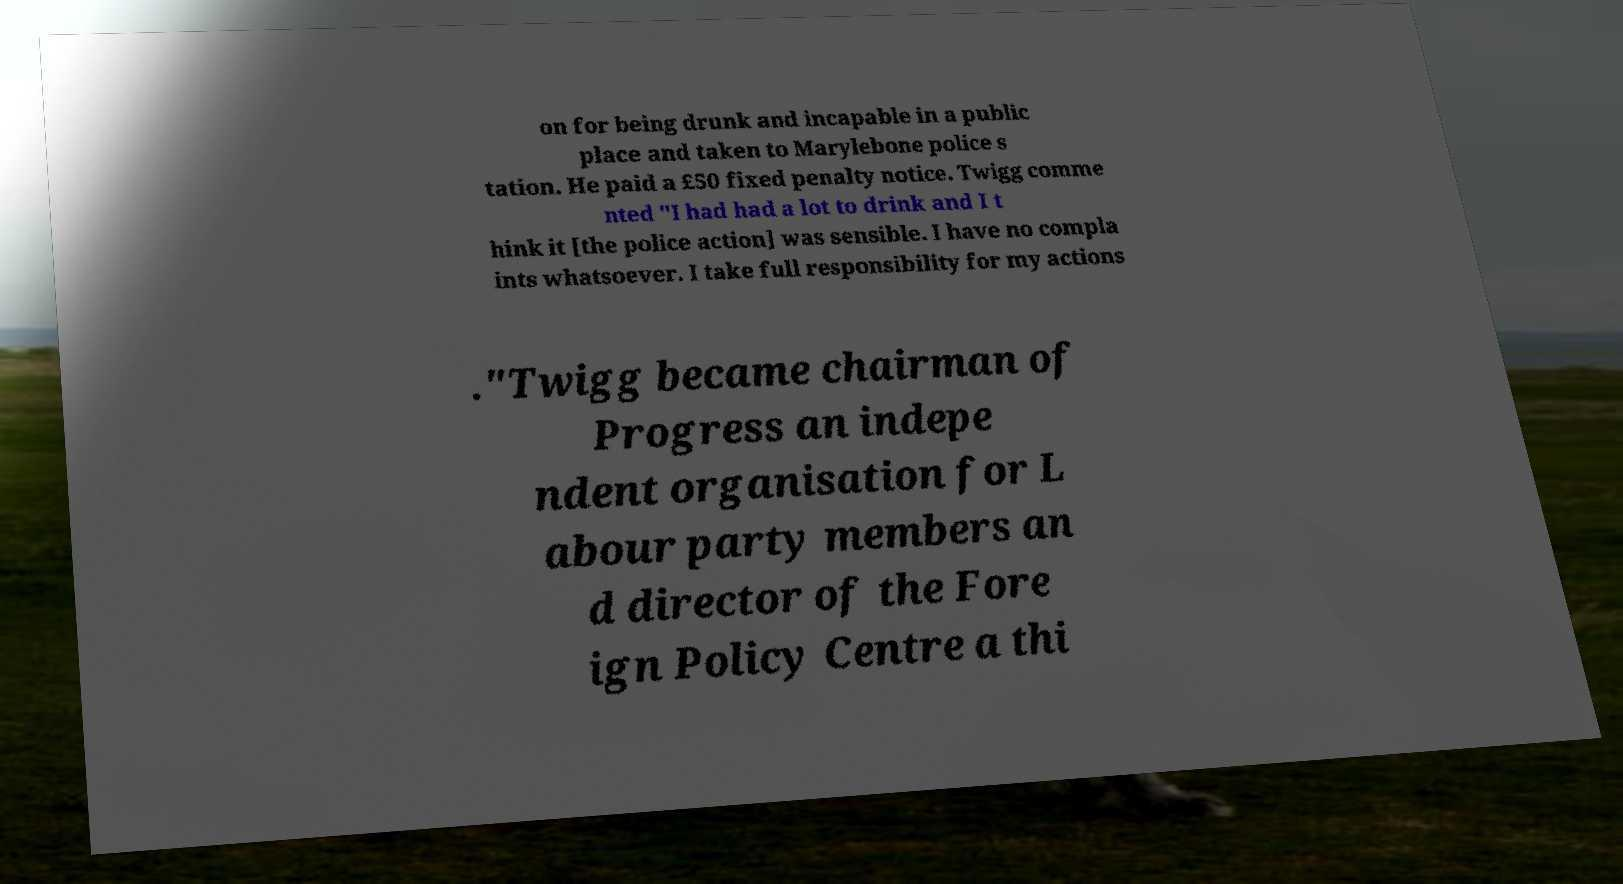I need the written content from this picture converted into text. Can you do that? on for being drunk and incapable in a public place and taken to Marylebone police s tation. He paid a £50 fixed penalty notice. Twigg comme nted "I had had a lot to drink and I t hink it [the police action] was sensible. I have no compla ints whatsoever. I take full responsibility for my actions ."Twigg became chairman of Progress an indepe ndent organisation for L abour party members an d director of the Fore ign Policy Centre a thi 